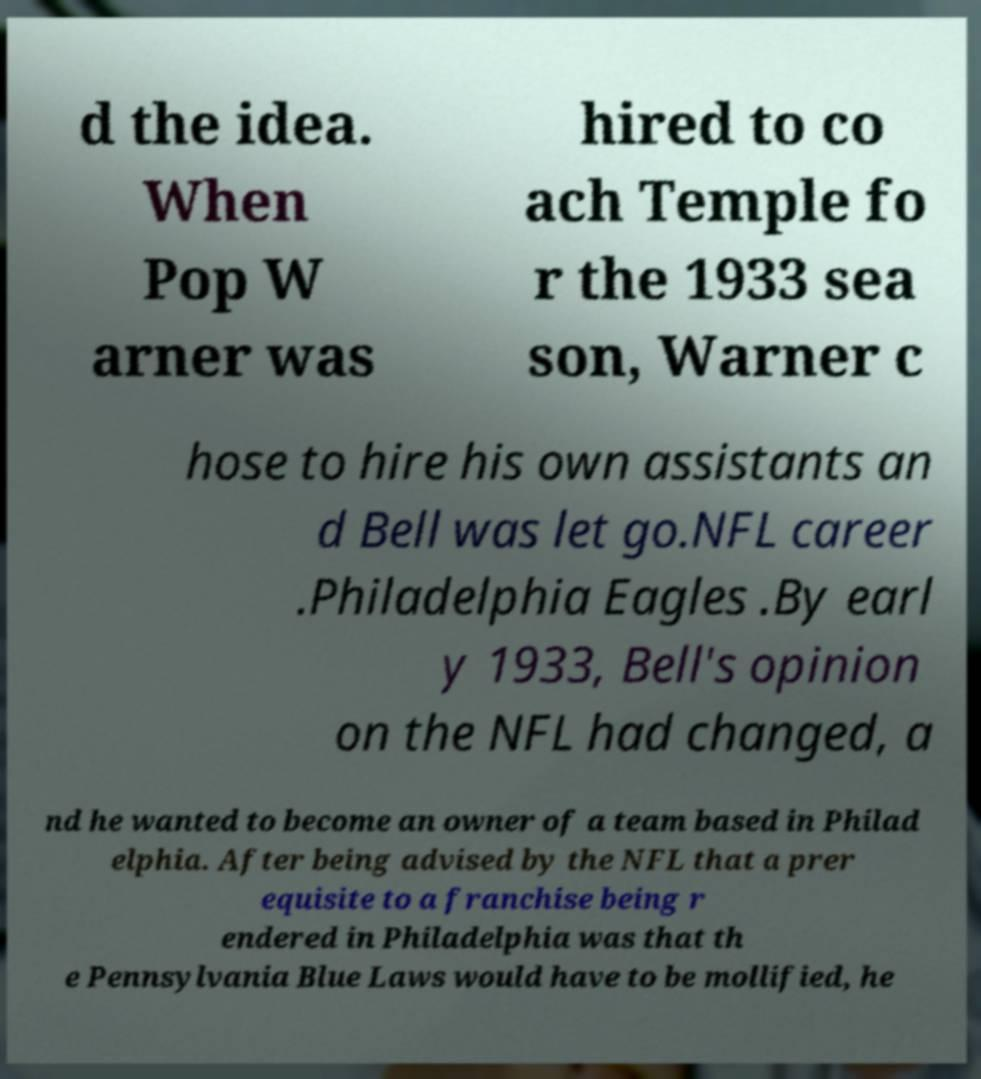Could you extract and type out the text from this image? d the idea. When Pop W arner was hired to co ach Temple fo r the 1933 sea son, Warner c hose to hire his own assistants an d Bell was let go.NFL career .Philadelphia Eagles .By earl y 1933, Bell's opinion on the NFL had changed, a nd he wanted to become an owner of a team based in Philad elphia. After being advised by the NFL that a prer equisite to a franchise being r endered in Philadelphia was that th e Pennsylvania Blue Laws would have to be mollified, he 